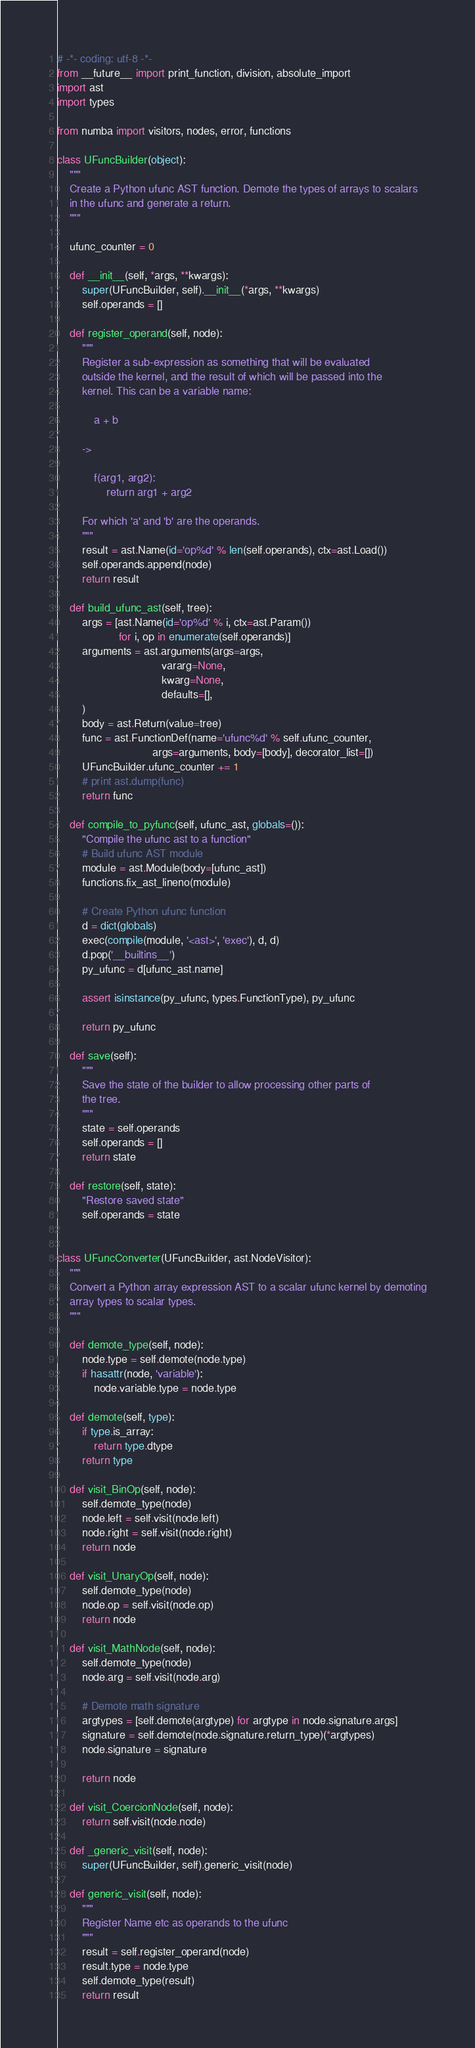<code> <loc_0><loc_0><loc_500><loc_500><_Python_># -*- coding: utf-8 -*-
from __future__ import print_function, division, absolute_import
import ast
import types

from numba import visitors, nodes, error, functions

class UFuncBuilder(object):
    """
    Create a Python ufunc AST function. Demote the types of arrays to scalars
    in the ufunc and generate a return.
    """

    ufunc_counter = 0

    def __init__(self, *args, **kwargs):
        super(UFuncBuilder, self).__init__(*args, **kwargs)
        self.operands = []

    def register_operand(self, node):
        """
        Register a sub-expression as something that will be evaluated
        outside the kernel, and the result of which will be passed into the
        kernel. This can be a variable name:

            a + b

        ->

            f(arg1, arg2):
                return arg1 + arg2

        For which 'a' and 'b' are the operands.
        """
        result = ast.Name(id='op%d' % len(self.operands), ctx=ast.Load())
        self.operands.append(node)
        return result

    def build_ufunc_ast(self, tree):
        args = [ast.Name(id='op%d' % i, ctx=ast.Param())
                    for i, op in enumerate(self.operands)]
        arguments = ast.arguments(args=args,
                                  vararg=None,
                                  kwarg=None,
                                  defaults=[],
        )
        body = ast.Return(value=tree)
        func = ast.FunctionDef(name='ufunc%d' % self.ufunc_counter,
                               args=arguments, body=[body], decorator_list=[])
        UFuncBuilder.ufunc_counter += 1
        # print ast.dump(func)
        return func

    def compile_to_pyfunc(self, ufunc_ast, globals=()):
        "Compile the ufunc ast to a function"
        # Build ufunc AST module
        module = ast.Module(body=[ufunc_ast])
        functions.fix_ast_lineno(module)

        # Create Python ufunc function
        d = dict(globals)
        exec(compile(module, '<ast>', 'exec'), d, d)
        d.pop('__builtins__')
        py_ufunc = d[ufunc_ast.name]

        assert isinstance(py_ufunc, types.FunctionType), py_ufunc

        return py_ufunc

    def save(self):
        """
        Save the state of the builder to allow processing other parts of
        the tree.
        """
        state = self.operands
        self.operands = []
        return state

    def restore(self, state):
        "Restore saved state"
        self.operands = state


class UFuncConverter(UFuncBuilder, ast.NodeVisitor):
    """
    Convert a Python array expression AST to a scalar ufunc kernel by demoting
    array types to scalar types.
    """

    def demote_type(self, node):
        node.type = self.demote(node.type)
        if hasattr(node, 'variable'):
            node.variable.type = node.type

    def demote(self, type):
        if type.is_array:
            return type.dtype
        return type

    def visit_BinOp(self, node):
        self.demote_type(node)
        node.left = self.visit(node.left)
        node.right = self.visit(node.right)
        return node

    def visit_UnaryOp(self, node):
        self.demote_type(node)
        node.op = self.visit(node.op)
        return node

    def visit_MathNode(self, node):
        self.demote_type(node)
        node.arg = self.visit(node.arg)

        # Demote math signature
        argtypes = [self.demote(argtype) for argtype in node.signature.args]
        signature = self.demote(node.signature.return_type)(*argtypes)
        node.signature = signature

        return node

    def visit_CoercionNode(self, node):
        return self.visit(node.node)

    def _generic_visit(self, node):
        super(UFuncBuilder, self).generic_visit(node)

    def generic_visit(self, node):
        """
        Register Name etc as operands to the ufunc
        """
        result = self.register_operand(node)
        result.type = node.type
        self.demote_type(result)
        return result
</code> 